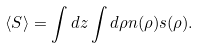Convert formula to latex. <formula><loc_0><loc_0><loc_500><loc_500>\langle S \rangle = \int d z \int d \rho n ( \rho ) s ( \rho ) .</formula> 